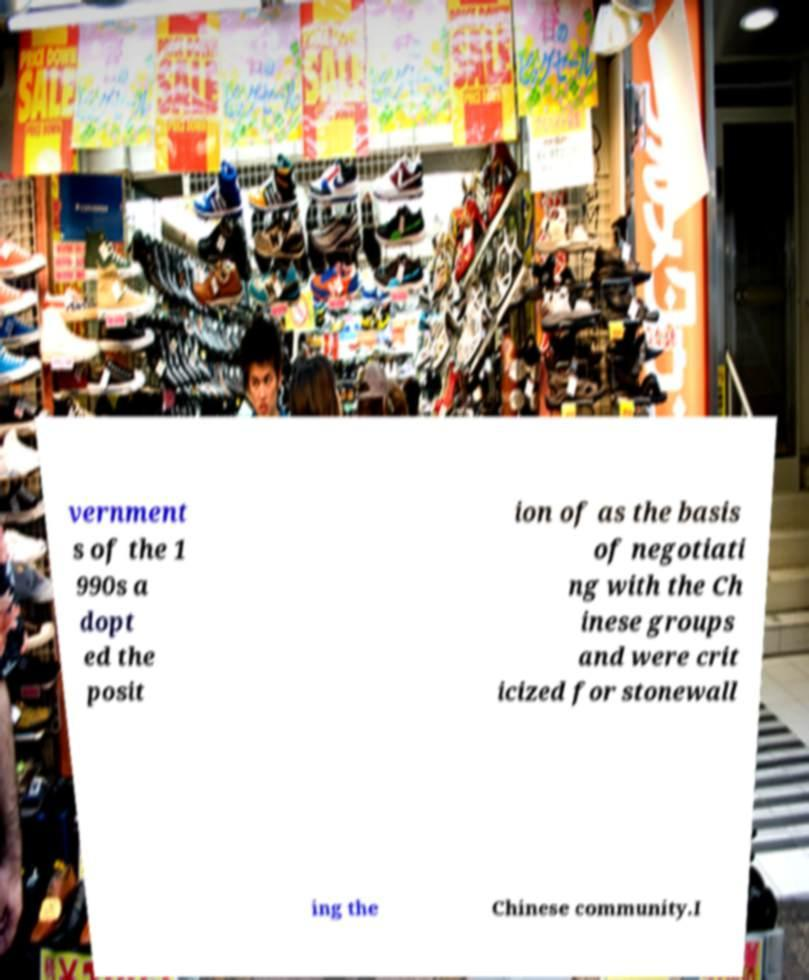There's text embedded in this image that I need extracted. Can you transcribe it verbatim? vernment s of the 1 990s a dopt ed the posit ion of as the basis of negotiati ng with the Ch inese groups and were crit icized for stonewall ing the Chinese community.I 